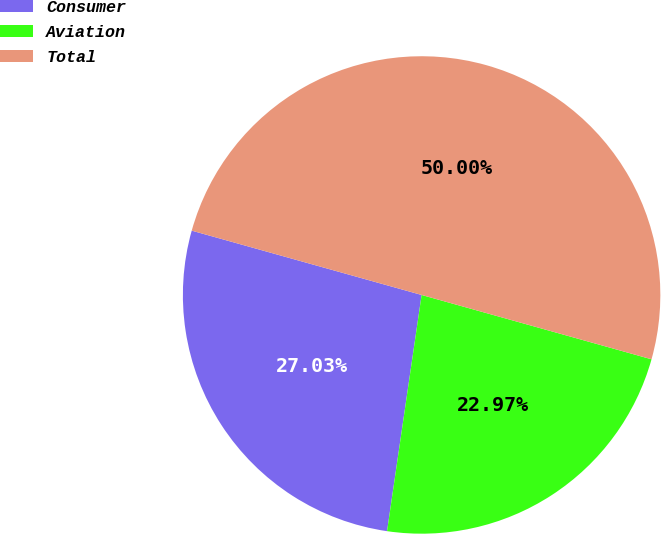Convert chart. <chart><loc_0><loc_0><loc_500><loc_500><pie_chart><fcel>Consumer<fcel>Aviation<fcel>Total<nl><fcel>27.03%<fcel>22.97%<fcel>50.0%<nl></chart> 